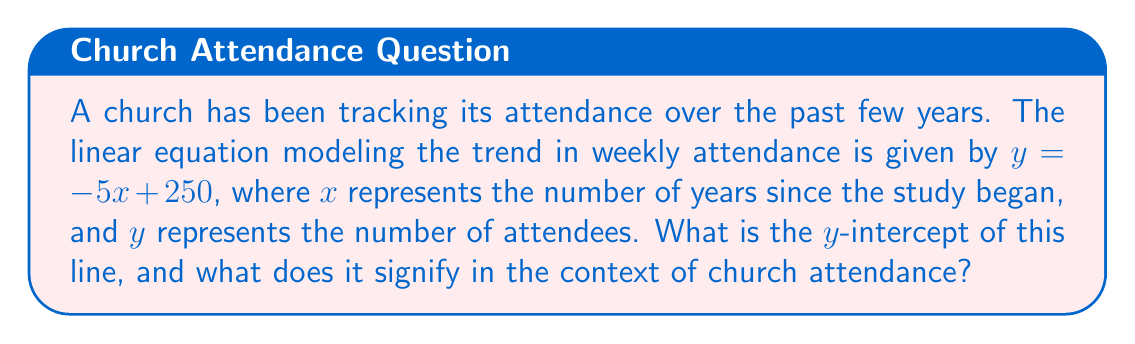Give your solution to this math problem. To find the y-intercept of a linear equation, we need to determine the value of $y$ when $x = 0$. The y-intercept represents the point where the line crosses the y-axis.

Given equation: $y = -5x + 250$

Step 1: Substitute $x = 0$ into the equation.
$y = -5(0) + 250$

Step 2: Simplify the equation.
$y = 0 + 250 = 250$

Therefore, the y-intercept is (0, 250).

In the context of church attendance, the y-intercept signifies the initial number of attendees when the study began (i.e., when $x = 0$). This means that at the start of the tracking period, the church had 250 attendees.

It's worth noting that the negative slope (-5) indicates a declining trend in attendance over time, which could be a point of concern for church leadership. This accurate representation of data is crucial for making informed decisions about outreach and community engagement strategies.
Answer: The y-intercept is 250. It represents the initial weekly church attendance of 250 people at the beginning of the study period. 